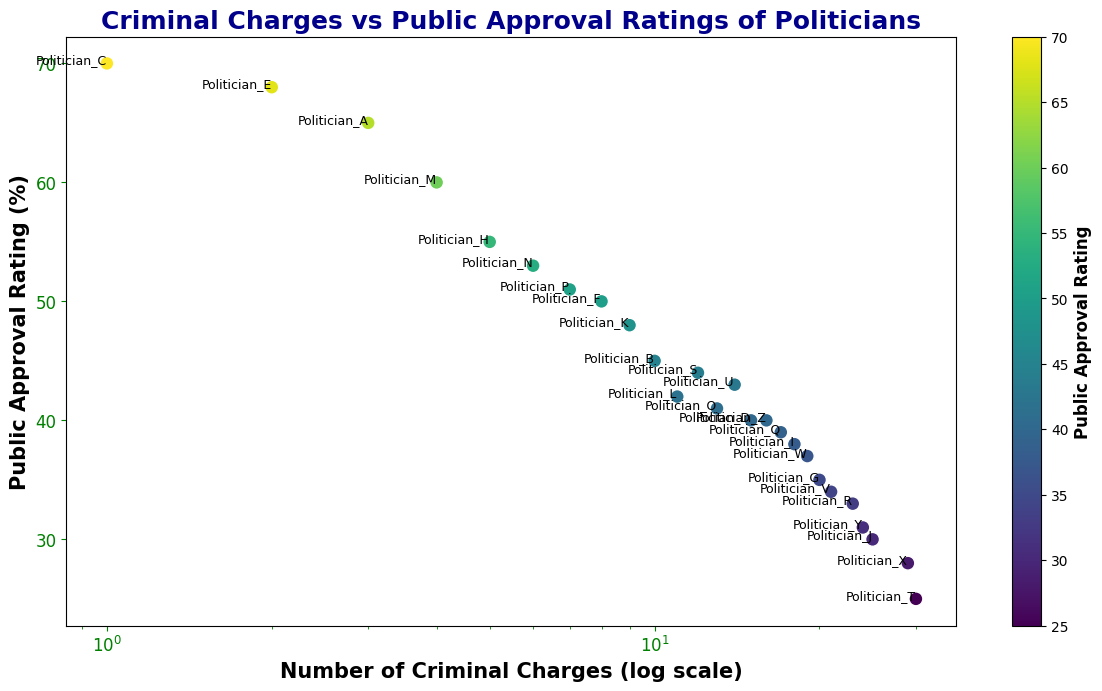What's the relationship between the number of criminal charges and public approval ratings generally indicated by the figure? The figure shows that politicians with higher numbers of criminal charges tend to have lower public approval ratings. This can be inferred from the general downward trend seen in the scatter plot—the points move from upper left to lower right.
Answer: Negative correlation Which politician has the highest number of criminal charges, and what is their public approval rating? Politician T has the highest number of criminal charges (30), and their public approval rating is 25%, as indicated by the point farthest to the right at the bottom of the plot.
Answer: Politician T, 25% What is the difference in public approval ratings between the politicians with the fewest and the most criminal charges? Politician C has the fewest criminal charges (1) with a public approval rating of 70%. Politician T has the most criminal charges (30) with a public approval rating of 25%. The difference is 70% - 25% = 45%.
Answer: 45% Which politician has a public approval rating closest to 50% and how many criminal charges do they have? Politician F has a public approval rating of 50% and they have 8 criminal charges, as indicated by the point around the middle of the plot.
Answer: Politician F, 8 charges Compare the public approval ratings of Politician B and Politician L. Which one is higher and by how much? Politician B has a public approval rating of 45%, and Politician L has a public approval rating of 42%. The difference is 45% - 42% = 3%, so Politician B's rating is higher by 3%.
Answer: Politician B, 3% What is the average number of criminal charges brought against politicians with public approval ratings below 40%? Politicians with public approval ratings below 40% include Politicians D (15 charges), G (20 charges), I (18 charges), Q (17 charges), and T (30 charges). Summing these together: 15 + 20 + 18 + 17 + 30 = 100. Dividing by 5 gives an average of 100/5 = 20.
Answer: 20 Identify the range of public approval ratings for politicians with criminal charges between 10 and 20. Politicians with criminal charges between 10 and 20 include Politician B (45%), L (42%), O (41%), Q (39%), S (44%), U (43%), V (34%), W (37%), Y (31%), and Z (40%). The range is from the lowest (31%) to the highest (45%), which gives a range of 45% - 31% = 14%.
Answer: 14% Which politician falls exactly on the logarithmic gridline of 10 criminal charges and what is their public approval rating? Politician B falls exactly on the logarithmic gridline of 10 criminal charges, and their public approval rating is 45%, shown by the point marked at (10, 45).
Answer: Politician B, 45% How many politicians have fewer than 5 criminal charges and at least 60% public approval rating? Politicians with fewer than 5 criminal charges include A (3), C (1), E (2), and M (4). Among these, Politician A has 65%, Politician C has 70%, and Politician E has 68%. Therefore, there are 3 politicians meeting both criteria.
Answer: 3 